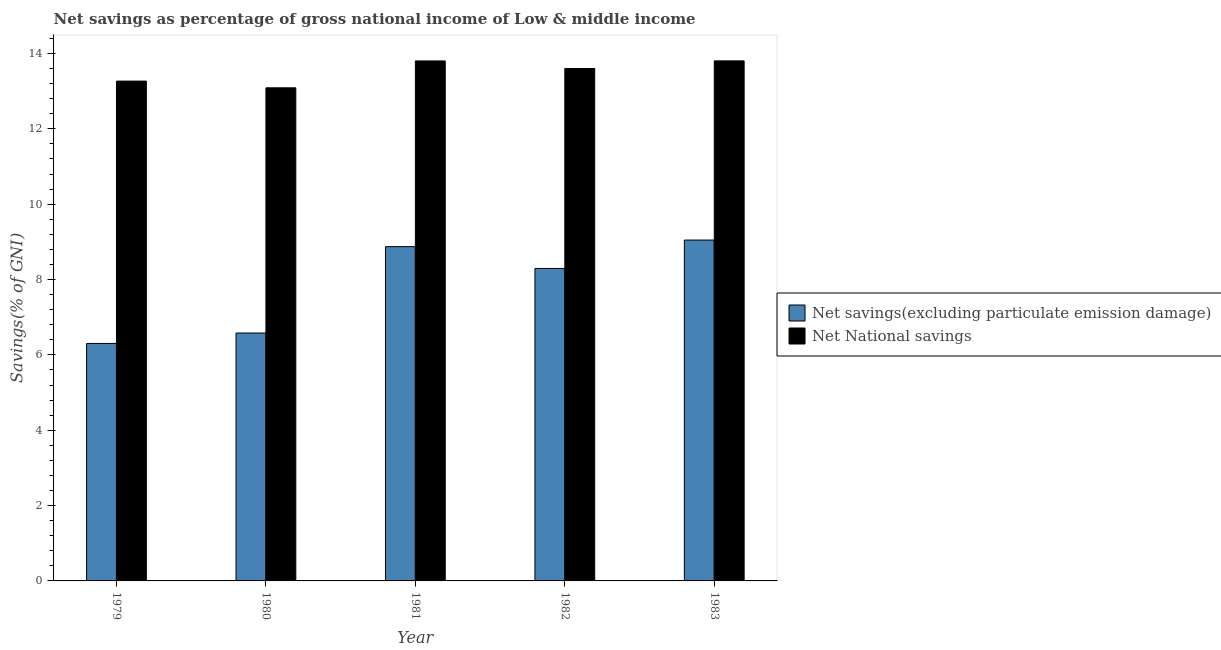How many groups of bars are there?
Your answer should be compact. 5. Are the number of bars per tick equal to the number of legend labels?
Provide a short and direct response. Yes. How many bars are there on the 5th tick from the left?
Give a very brief answer. 2. What is the label of the 4th group of bars from the left?
Offer a very short reply. 1982. In how many cases, is the number of bars for a given year not equal to the number of legend labels?
Ensure brevity in your answer.  0. What is the net savings(excluding particulate emission damage) in 1981?
Make the answer very short. 8.87. Across all years, what is the maximum net savings(excluding particulate emission damage)?
Keep it short and to the point. 9.05. Across all years, what is the minimum net savings(excluding particulate emission damage)?
Provide a short and direct response. 6.3. In which year was the net savings(excluding particulate emission damage) maximum?
Offer a terse response. 1983. What is the total net savings(excluding particulate emission damage) in the graph?
Provide a short and direct response. 39.1. What is the difference between the net savings(excluding particulate emission damage) in 1980 and that in 1981?
Give a very brief answer. -2.29. What is the difference between the net national savings in 1982 and the net savings(excluding particulate emission damage) in 1983?
Offer a terse response. -0.2. What is the average net savings(excluding particulate emission damage) per year?
Your answer should be compact. 7.82. In the year 1982, what is the difference between the net national savings and net savings(excluding particulate emission damage)?
Provide a short and direct response. 0. What is the ratio of the net savings(excluding particulate emission damage) in 1979 to that in 1983?
Your answer should be compact. 0.7. Is the net savings(excluding particulate emission damage) in 1982 less than that in 1983?
Give a very brief answer. Yes. Is the difference between the net savings(excluding particulate emission damage) in 1981 and 1982 greater than the difference between the net national savings in 1981 and 1982?
Offer a very short reply. No. What is the difference between the highest and the second highest net savings(excluding particulate emission damage)?
Provide a short and direct response. 0.17. What is the difference between the highest and the lowest net national savings?
Make the answer very short. 0.72. In how many years, is the net national savings greater than the average net national savings taken over all years?
Your response must be concise. 3. Is the sum of the net savings(excluding particulate emission damage) in 1979 and 1980 greater than the maximum net national savings across all years?
Your response must be concise. Yes. What does the 1st bar from the left in 1981 represents?
Your answer should be compact. Net savings(excluding particulate emission damage). What does the 2nd bar from the right in 1982 represents?
Provide a succinct answer. Net savings(excluding particulate emission damage). Are the values on the major ticks of Y-axis written in scientific E-notation?
Ensure brevity in your answer.  No. Where does the legend appear in the graph?
Provide a succinct answer. Center right. What is the title of the graph?
Your response must be concise. Net savings as percentage of gross national income of Low & middle income. Does "Netherlands" appear as one of the legend labels in the graph?
Ensure brevity in your answer.  No. What is the label or title of the Y-axis?
Offer a terse response. Savings(% of GNI). What is the Savings(% of GNI) in Net savings(excluding particulate emission damage) in 1979?
Your answer should be very brief. 6.3. What is the Savings(% of GNI) of Net National savings in 1979?
Provide a succinct answer. 13.27. What is the Savings(% of GNI) of Net savings(excluding particulate emission damage) in 1980?
Give a very brief answer. 6.58. What is the Savings(% of GNI) in Net National savings in 1980?
Make the answer very short. 13.09. What is the Savings(% of GNI) in Net savings(excluding particulate emission damage) in 1981?
Provide a short and direct response. 8.87. What is the Savings(% of GNI) in Net National savings in 1981?
Provide a succinct answer. 13.8. What is the Savings(% of GNI) in Net savings(excluding particulate emission damage) in 1982?
Ensure brevity in your answer.  8.29. What is the Savings(% of GNI) in Net National savings in 1982?
Keep it short and to the point. 13.6. What is the Savings(% of GNI) in Net savings(excluding particulate emission damage) in 1983?
Ensure brevity in your answer.  9.05. What is the Savings(% of GNI) of Net National savings in 1983?
Keep it short and to the point. 13.8. Across all years, what is the maximum Savings(% of GNI) of Net savings(excluding particulate emission damage)?
Provide a succinct answer. 9.05. Across all years, what is the maximum Savings(% of GNI) in Net National savings?
Provide a short and direct response. 13.8. Across all years, what is the minimum Savings(% of GNI) in Net savings(excluding particulate emission damage)?
Make the answer very short. 6.3. Across all years, what is the minimum Savings(% of GNI) of Net National savings?
Ensure brevity in your answer.  13.09. What is the total Savings(% of GNI) in Net savings(excluding particulate emission damage) in the graph?
Ensure brevity in your answer.  39.1. What is the total Savings(% of GNI) in Net National savings in the graph?
Offer a very short reply. 67.56. What is the difference between the Savings(% of GNI) of Net savings(excluding particulate emission damage) in 1979 and that in 1980?
Offer a very short reply. -0.28. What is the difference between the Savings(% of GNI) in Net National savings in 1979 and that in 1980?
Offer a very short reply. 0.18. What is the difference between the Savings(% of GNI) in Net savings(excluding particulate emission damage) in 1979 and that in 1981?
Make the answer very short. -2.57. What is the difference between the Savings(% of GNI) in Net National savings in 1979 and that in 1981?
Your answer should be compact. -0.53. What is the difference between the Savings(% of GNI) in Net savings(excluding particulate emission damage) in 1979 and that in 1982?
Provide a short and direct response. -1.99. What is the difference between the Savings(% of GNI) of Net National savings in 1979 and that in 1982?
Your answer should be compact. -0.33. What is the difference between the Savings(% of GNI) in Net savings(excluding particulate emission damage) in 1979 and that in 1983?
Ensure brevity in your answer.  -2.74. What is the difference between the Savings(% of GNI) of Net National savings in 1979 and that in 1983?
Keep it short and to the point. -0.54. What is the difference between the Savings(% of GNI) in Net savings(excluding particulate emission damage) in 1980 and that in 1981?
Make the answer very short. -2.29. What is the difference between the Savings(% of GNI) in Net National savings in 1980 and that in 1981?
Keep it short and to the point. -0.71. What is the difference between the Savings(% of GNI) of Net savings(excluding particulate emission damage) in 1980 and that in 1982?
Make the answer very short. -1.71. What is the difference between the Savings(% of GNI) in Net National savings in 1980 and that in 1982?
Provide a short and direct response. -0.51. What is the difference between the Savings(% of GNI) in Net savings(excluding particulate emission damage) in 1980 and that in 1983?
Make the answer very short. -2.47. What is the difference between the Savings(% of GNI) of Net National savings in 1980 and that in 1983?
Your answer should be very brief. -0.72. What is the difference between the Savings(% of GNI) of Net savings(excluding particulate emission damage) in 1981 and that in 1982?
Offer a terse response. 0.58. What is the difference between the Savings(% of GNI) in Net National savings in 1981 and that in 1982?
Ensure brevity in your answer.  0.2. What is the difference between the Savings(% of GNI) in Net savings(excluding particulate emission damage) in 1981 and that in 1983?
Provide a succinct answer. -0.17. What is the difference between the Savings(% of GNI) in Net National savings in 1981 and that in 1983?
Provide a succinct answer. -0. What is the difference between the Savings(% of GNI) in Net savings(excluding particulate emission damage) in 1982 and that in 1983?
Offer a very short reply. -0.75. What is the difference between the Savings(% of GNI) of Net National savings in 1982 and that in 1983?
Offer a terse response. -0.2. What is the difference between the Savings(% of GNI) in Net savings(excluding particulate emission damage) in 1979 and the Savings(% of GNI) in Net National savings in 1980?
Offer a very short reply. -6.78. What is the difference between the Savings(% of GNI) in Net savings(excluding particulate emission damage) in 1979 and the Savings(% of GNI) in Net National savings in 1981?
Keep it short and to the point. -7.5. What is the difference between the Savings(% of GNI) of Net savings(excluding particulate emission damage) in 1979 and the Savings(% of GNI) of Net National savings in 1982?
Give a very brief answer. -7.3. What is the difference between the Savings(% of GNI) in Net savings(excluding particulate emission damage) in 1979 and the Savings(% of GNI) in Net National savings in 1983?
Offer a terse response. -7.5. What is the difference between the Savings(% of GNI) in Net savings(excluding particulate emission damage) in 1980 and the Savings(% of GNI) in Net National savings in 1981?
Ensure brevity in your answer.  -7.22. What is the difference between the Savings(% of GNI) in Net savings(excluding particulate emission damage) in 1980 and the Savings(% of GNI) in Net National savings in 1982?
Your answer should be compact. -7.02. What is the difference between the Savings(% of GNI) of Net savings(excluding particulate emission damage) in 1980 and the Savings(% of GNI) of Net National savings in 1983?
Your answer should be very brief. -7.22. What is the difference between the Savings(% of GNI) in Net savings(excluding particulate emission damage) in 1981 and the Savings(% of GNI) in Net National savings in 1982?
Offer a terse response. -4.73. What is the difference between the Savings(% of GNI) in Net savings(excluding particulate emission damage) in 1981 and the Savings(% of GNI) in Net National savings in 1983?
Provide a short and direct response. -4.93. What is the difference between the Savings(% of GNI) of Net savings(excluding particulate emission damage) in 1982 and the Savings(% of GNI) of Net National savings in 1983?
Ensure brevity in your answer.  -5.51. What is the average Savings(% of GNI) of Net savings(excluding particulate emission damage) per year?
Make the answer very short. 7.82. What is the average Savings(% of GNI) in Net National savings per year?
Provide a short and direct response. 13.51. In the year 1979, what is the difference between the Savings(% of GNI) of Net savings(excluding particulate emission damage) and Savings(% of GNI) of Net National savings?
Your response must be concise. -6.96. In the year 1980, what is the difference between the Savings(% of GNI) of Net savings(excluding particulate emission damage) and Savings(% of GNI) of Net National savings?
Ensure brevity in your answer.  -6.51. In the year 1981, what is the difference between the Savings(% of GNI) of Net savings(excluding particulate emission damage) and Savings(% of GNI) of Net National savings?
Give a very brief answer. -4.93. In the year 1982, what is the difference between the Savings(% of GNI) in Net savings(excluding particulate emission damage) and Savings(% of GNI) in Net National savings?
Your answer should be compact. -5.31. In the year 1983, what is the difference between the Savings(% of GNI) of Net savings(excluding particulate emission damage) and Savings(% of GNI) of Net National savings?
Give a very brief answer. -4.76. What is the ratio of the Savings(% of GNI) of Net savings(excluding particulate emission damage) in 1979 to that in 1980?
Keep it short and to the point. 0.96. What is the ratio of the Savings(% of GNI) in Net National savings in 1979 to that in 1980?
Your answer should be very brief. 1.01. What is the ratio of the Savings(% of GNI) in Net savings(excluding particulate emission damage) in 1979 to that in 1981?
Keep it short and to the point. 0.71. What is the ratio of the Savings(% of GNI) in Net National savings in 1979 to that in 1981?
Make the answer very short. 0.96. What is the ratio of the Savings(% of GNI) in Net savings(excluding particulate emission damage) in 1979 to that in 1982?
Give a very brief answer. 0.76. What is the ratio of the Savings(% of GNI) of Net National savings in 1979 to that in 1982?
Keep it short and to the point. 0.98. What is the ratio of the Savings(% of GNI) in Net savings(excluding particulate emission damage) in 1979 to that in 1983?
Offer a very short reply. 0.7. What is the ratio of the Savings(% of GNI) of Net National savings in 1979 to that in 1983?
Offer a terse response. 0.96. What is the ratio of the Savings(% of GNI) in Net savings(excluding particulate emission damage) in 1980 to that in 1981?
Offer a very short reply. 0.74. What is the ratio of the Savings(% of GNI) in Net National savings in 1980 to that in 1981?
Provide a succinct answer. 0.95. What is the ratio of the Savings(% of GNI) of Net savings(excluding particulate emission damage) in 1980 to that in 1982?
Your response must be concise. 0.79. What is the ratio of the Savings(% of GNI) of Net National savings in 1980 to that in 1982?
Your response must be concise. 0.96. What is the ratio of the Savings(% of GNI) of Net savings(excluding particulate emission damage) in 1980 to that in 1983?
Your answer should be compact. 0.73. What is the ratio of the Savings(% of GNI) in Net National savings in 1980 to that in 1983?
Give a very brief answer. 0.95. What is the ratio of the Savings(% of GNI) of Net savings(excluding particulate emission damage) in 1981 to that in 1982?
Ensure brevity in your answer.  1.07. What is the ratio of the Savings(% of GNI) of Net National savings in 1981 to that in 1982?
Offer a very short reply. 1.01. What is the ratio of the Savings(% of GNI) of Net savings(excluding particulate emission damage) in 1981 to that in 1983?
Give a very brief answer. 0.98. What is the ratio of the Savings(% of GNI) in Net savings(excluding particulate emission damage) in 1982 to that in 1983?
Provide a succinct answer. 0.92. What is the ratio of the Savings(% of GNI) of Net National savings in 1982 to that in 1983?
Provide a succinct answer. 0.99. What is the difference between the highest and the second highest Savings(% of GNI) in Net savings(excluding particulate emission damage)?
Offer a very short reply. 0.17. What is the difference between the highest and the second highest Savings(% of GNI) of Net National savings?
Your answer should be compact. 0. What is the difference between the highest and the lowest Savings(% of GNI) in Net savings(excluding particulate emission damage)?
Keep it short and to the point. 2.74. What is the difference between the highest and the lowest Savings(% of GNI) in Net National savings?
Give a very brief answer. 0.72. 